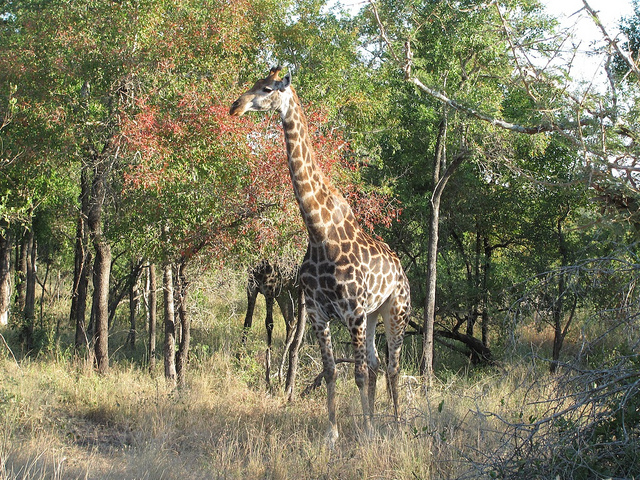How many giraffe are in the forest? There is one giraffe visible amidst the trees in this forested area. Its long neck and spotted pattern are characteristic of its species, standing out against the greenery of the forest. 